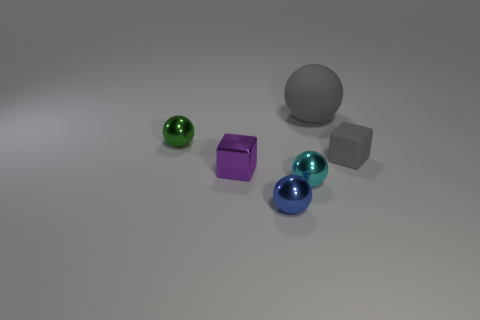Subtract all tiny green balls. How many balls are left? 3 Add 2 small blue things. How many objects exist? 8 Subtract 3 spheres. How many spheres are left? 1 Subtract all purple cubes. How many cubes are left? 1 Subtract all blocks. How many objects are left? 4 Add 6 blue shiny things. How many blue shiny things are left? 7 Add 4 cyan objects. How many cyan objects exist? 5 Subtract 0 red cylinders. How many objects are left? 6 Subtract all brown cubes. Subtract all green balls. How many cubes are left? 2 Subtract all tiny purple things. Subtract all tiny blue objects. How many objects are left? 4 